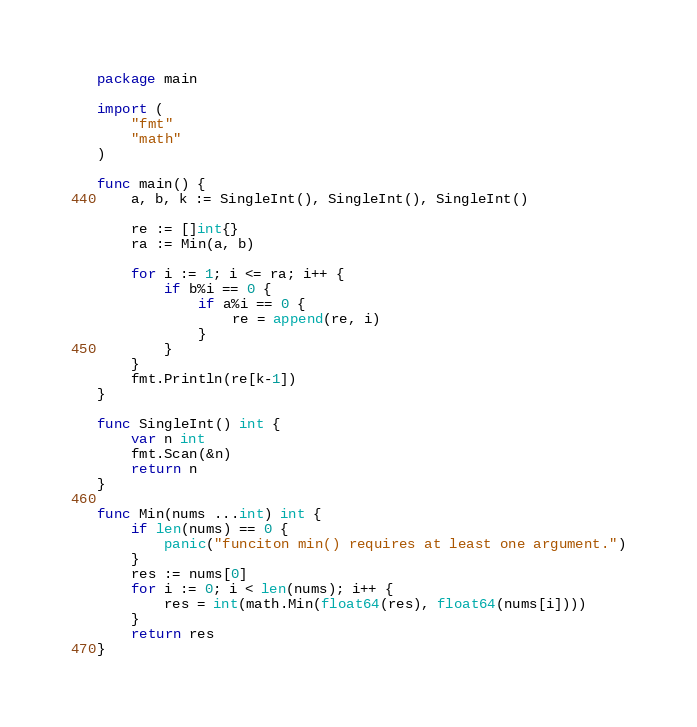Convert code to text. <code><loc_0><loc_0><loc_500><loc_500><_Go_>package main

import (
	"fmt"
	"math"
)

func main() {
	a, b, k := SingleInt(), SingleInt(), SingleInt()

	re := []int{}
	ra := Min(a, b)

	for i := 1; i <= ra; i++ {
		if b%i == 0 {
			if a%i == 0 {
				re = append(re, i)
			}
		}
	}
	fmt.Println(re[k-1])
}

func SingleInt() int {
	var n int
	fmt.Scan(&n)
	return n
}

func Min(nums ...int) int {
	if len(nums) == 0 {
		panic("funciton min() requires at least one argument.")
	}
	res := nums[0]
	for i := 0; i < len(nums); i++ {
		res = int(math.Min(float64(res), float64(nums[i])))
	}
	return res
}
</code> 